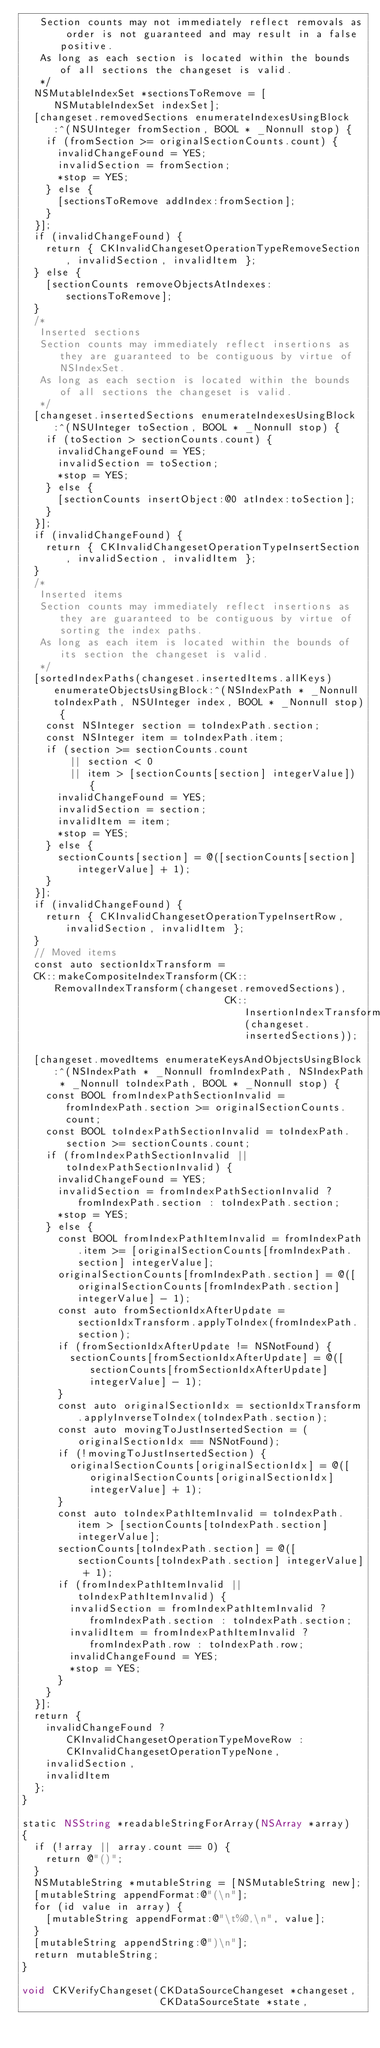Convert code to text. <code><loc_0><loc_0><loc_500><loc_500><_ObjectiveC_>   Section counts may not immediately reflect removals as order is not guaranteed and may result in a false positive.
   As long as each section is located within the bounds of all sections the changeset is valid.
   */
  NSMutableIndexSet *sectionsToRemove = [NSMutableIndexSet indexSet];
  [changeset.removedSections enumerateIndexesUsingBlock:^(NSUInteger fromSection, BOOL * _Nonnull stop) {
    if (fromSection >= originalSectionCounts.count) {
      invalidChangeFound = YES;
      invalidSection = fromSection;
      *stop = YES;
    } else {
      [sectionsToRemove addIndex:fromSection];
    }
  }];
  if (invalidChangeFound) {
    return { CKInvalidChangesetOperationTypeRemoveSection, invalidSection, invalidItem };
  } else {
    [sectionCounts removeObjectsAtIndexes:sectionsToRemove];
  }
  /*
   Inserted sections
   Section counts may immediately reflect insertions as they are guaranteed to be contiguous by virtue of NSIndexSet.
   As long as each section is located within the bounds of all sections the changeset is valid.
   */
  [changeset.insertedSections enumerateIndexesUsingBlock:^(NSUInteger toSection, BOOL * _Nonnull stop) {
    if (toSection > sectionCounts.count) {
      invalidChangeFound = YES;
      invalidSection = toSection;
      *stop = YES;
    } else {
      [sectionCounts insertObject:@0 atIndex:toSection];
    }
  }];
  if (invalidChangeFound) {
    return { CKInvalidChangesetOperationTypeInsertSection, invalidSection, invalidItem };
  }
  /*
   Inserted items
   Section counts may immediately reflect insertions as they are guaranteed to be contiguous by virtue of sorting the index paths.
   As long as each item is located within the bounds of its section the changeset is valid.
   */
  [sortedIndexPaths(changeset.insertedItems.allKeys) enumerateObjectsUsingBlock:^(NSIndexPath * _Nonnull toIndexPath, NSUInteger index, BOOL * _Nonnull stop) {
    const NSInteger section = toIndexPath.section;
    const NSInteger item = toIndexPath.item;
    if (section >= sectionCounts.count
        || section < 0
        || item > [sectionCounts[section] integerValue]) {
      invalidChangeFound = YES;
      invalidSection = section;
      invalidItem = item;
      *stop = YES;
    } else {
      sectionCounts[section] = @([sectionCounts[section] integerValue] + 1);
    }
  }];
  if (invalidChangeFound) {
    return { CKInvalidChangesetOperationTypeInsertRow, invalidSection, invalidItem };
  }
  // Moved items
  const auto sectionIdxTransform =
  CK::makeCompositeIndexTransform(CK::RemovalIndexTransform(changeset.removedSections),
                                  CK::InsertionIndexTransform(changeset.insertedSections));
  
  [changeset.movedItems enumerateKeysAndObjectsUsingBlock:^(NSIndexPath * _Nonnull fromIndexPath, NSIndexPath * _Nonnull toIndexPath, BOOL * _Nonnull stop) {
    const BOOL fromIndexPathSectionInvalid = fromIndexPath.section >= originalSectionCounts.count;
    const BOOL toIndexPathSectionInvalid = toIndexPath.section >= sectionCounts.count;
    if (fromIndexPathSectionInvalid || toIndexPathSectionInvalid) {
      invalidChangeFound = YES;
      invalidSection = fromIndexPathSectionInvalid ? fromIndexPath.section : toIndexPath.section;
      *stop = YES;
    } else {
      const BOOL fromIndexPathItemInvalid = fromIndexPath.item >= [originalSectionCounts[fromIndexPath.section] integerValue];
      originalSectionCounts[fromIndexPath.section] = @([originalSectionCounts[fromIndexPath.section] integerValue] - 1);
      const auto fromSectionIdxAfterUpdate = sectionIdxTransform.applyToIndex(fromIndexPath.section);
      if (fromSectionIdxAfterUpdate != NSNotFound) {
        sectionCounts[fromSectionIdxAfterUpdate] = @([sectionCounts[fromSectionIdxAfterUpdate] integerValue] - 1);
      }
      const auto originalSectionIdx = sectionIdxTransform.applyInverseToIndex(toIndexPath.section);
      const auto movingToJustInsertedSection = (originalSectionIdx == NSNotFound);
      if (!movingToJustInsertedSection) {
        originalSectionCounts[originalSectionIdx] = @([originalSectionCounts[originalSectionIdx] integerValue] + 1);
      }
      const auto toIndexPathItemInvalid = toIndexPath.item > [sectionCounts[toIndexPath.section] integerValue];
      sectionCounts[toIndexPath.section] = @([sectionCounts[toIndexPath.section] integerValue] + 1);
      if (fromIndexPathItemInvalid || toIndexPathItemInvalid) {
        invalidSection = fromIndexPathItemInvalid ? fromIndexPath.section : toIndexPath.section;
        invalidItem = fromIndexPathItemInvalid ? fromIndexPath.row : toIndexPath.row;
        invalidChangeFound = YES;
        *stop = YES;
      }
    }
  }];
  return {
    invalidChangeFound ? CKInvalidChangesetOperationTypeMoveRow : CKInvalidChangesetOperationTypeNone,
    invalidSection,
    invalidItem
  };
}

static NSString *readableStringForArray(NSArray *array)
{
  if (!array || array.count == 0) {
    return @"()";
  }
  NSMutableString *mutableString = [NSMutableString new];
  [mutableString appendFormat:@"(\n"];
  for (id value in array) {
    [mutableString appendFormat:@"\t%@,\n", value];
  }
  [mutableString appendString:@")\n"];
  return mutableString;
}

void CKVerifyChangeset(CKDataSourceChangeset *changeset,
                       CKDataSourceState *state,</code> 